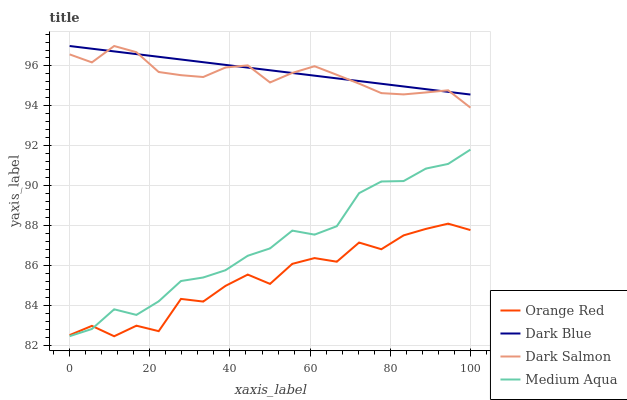Does Orange Red have the minimum area under the curve?
Answer yes or no. Yes. Does Dark Blue have the maximum area under the curve?
Answer yes or no. Yes. Does Medium Aqua have the minimum area under the curve?
Answer yes or no. No. Does Medium Aqua have the maximum area under the curve?
Answer yes or no. No. Is Dark Blue the smoothest?
Answer yes or no. Yes. Is Orange Red the roughest?
Answer yes or no. Yes. Is Medium Aqua the smoothest?
Answer yes or no. No. Is Medium Aqua the roughest?
Answer yes or no. No. Does Orange Red have the lowest value?
Answer yes or no. Yes. Does Medium Aqua have the lowest value?
Answer yes or no. No. Does Dark Salmon have the highest value?
Answer yes or no. Yes. Does Medium Aqua have the highest value?
Answer yes or no. No. Is Orange Red less than Dark Salmon?
Answer yes or no. Yes. Is Dark Salmon greater than Orange Red?
Answer yes or no. Yes. Does Orange Red intersect Medium Aqua?
Answer yes or no. Yes. Is Orange Red less than Medium Aqua?
Answer yes or no. No. Is Orange Red greater than Medium Aqua?
Answer yes or no. No. Does Orange Red intersect Dark Salmon?
Answer yes or no. No. 